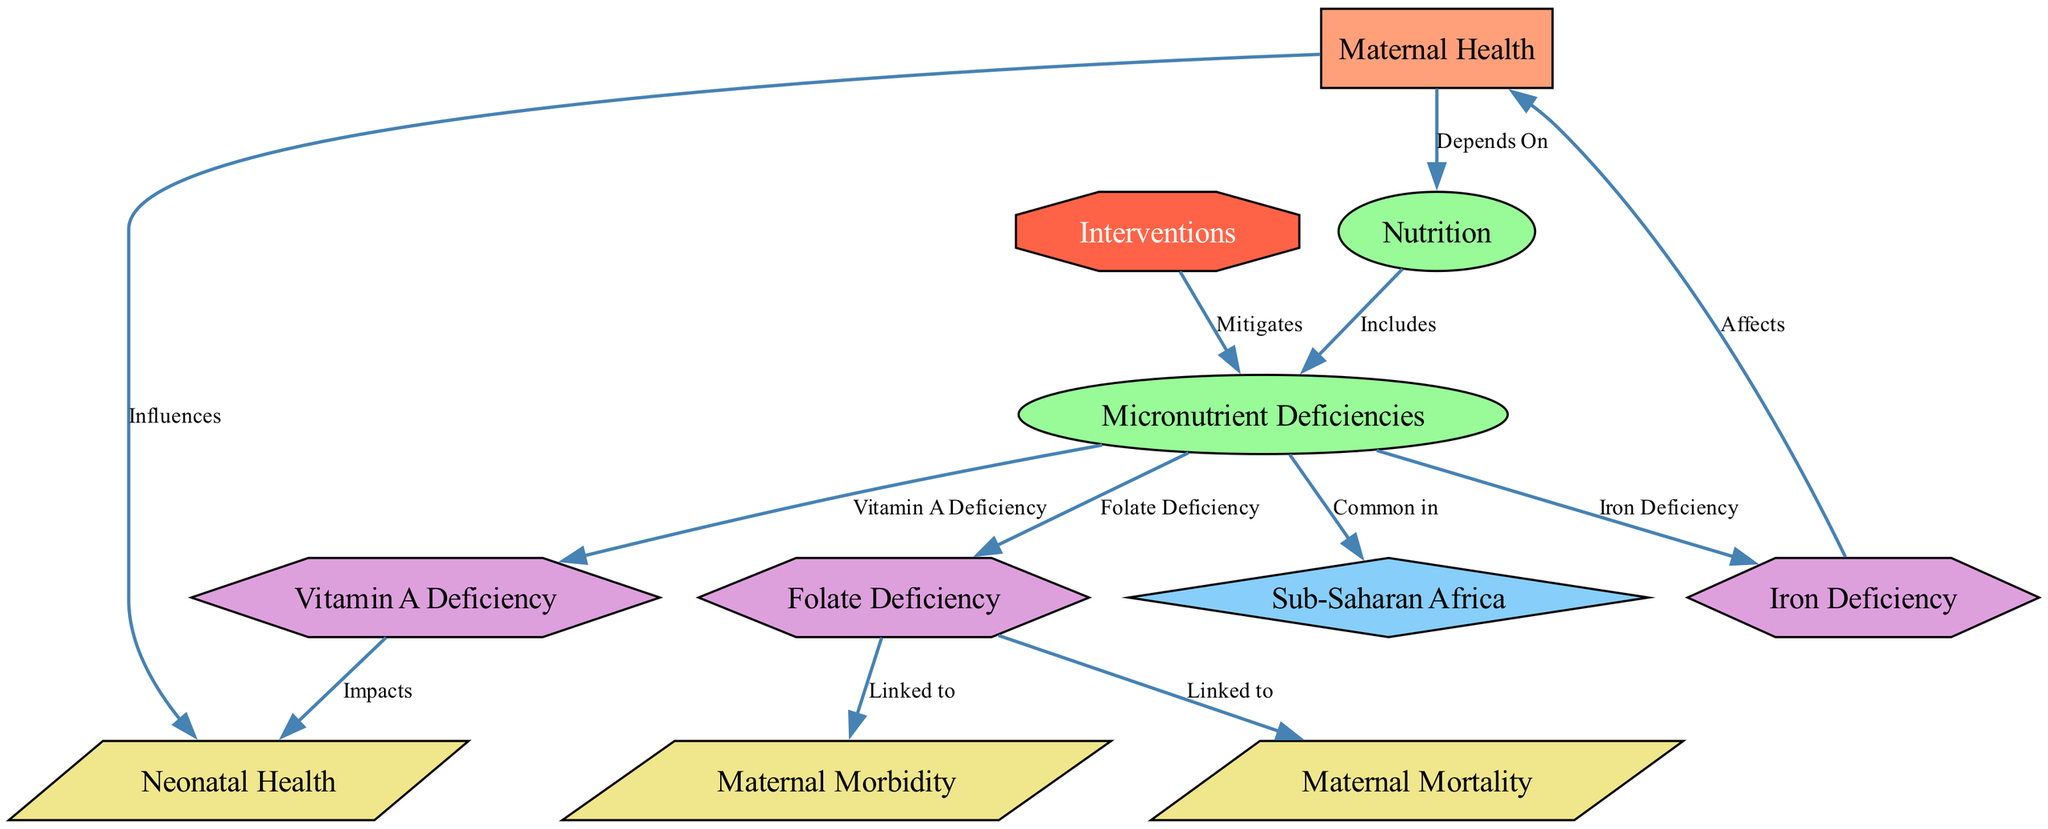What is the main topic of the diagram? The diagram is centered around "Maternal Health," identified as the main topic node. This can be found at the top of the diagram.
Answer: Maternal Health How many micronutrient deficiencies are identified in the diagram? The diagram lists three specific micronutrient deficiencies: Iron Deficiency, Vitamin A Deficiency, and Folate Deficiency. This can be counted by examining the connections from the "micronutrient_deficiencies" node.
Answer: Three Which context is associated with micronutrient deficiencies? The diagram shows that "Micronutrient Deficiencies" are common in "Sub-Saharan Africa," as indicated by the connecting edge labeled "Common in." This connection can be traced from the micronutrient deficiencies node to the context node.
Answer: Sub-Saharan Africa What impact does Vitamin A Deficiency have according to the diagram? The diagram indicates that "Vitamin A Deficiency" impacts "Neonatal Health," as shown by the directed edge labeled "Impacts." This illustrates the relationship between the micronutrient and its effect.
Answer: Neonatal Health How does Folate Deficiency affect maternal health outcomes? The diagram links "Folate Deficiency" to both "Maternal Morbidity" and "Maternal Mortality." This indicates that deficits in folate are connected to negative health outcomes for mothers. Thus, it specifically affects both morbidity and mortality.
Answer: Morbidity and Mortality What is the role of interventions in relation to micronutrient deficiencies? The edge labeled "Mitigates" shows that interventions are aimed at reducing or alleviating the impact of "Micronutrient Deficiencies." This relationship helps clarify the function of intervention strategies in health outcomes.
Answer: Mitigates How do maternal health and neonatal health relate in the diagram? The diagram indicates a direct influence of "Maternal Health" on "Neonatal Health," illustrated by the edge labeled "Influences." This shows that the health of the mother can directly affect the health of newborns.
Answer: Influences Which micronutrient is specifically linked to maternal health? The diagram indicates that "Iron Deficiency" affects "Maternal Health." The directed edge labeled "Affects" demonstrates this specific relationship.
Answer: Iron Deficiency 